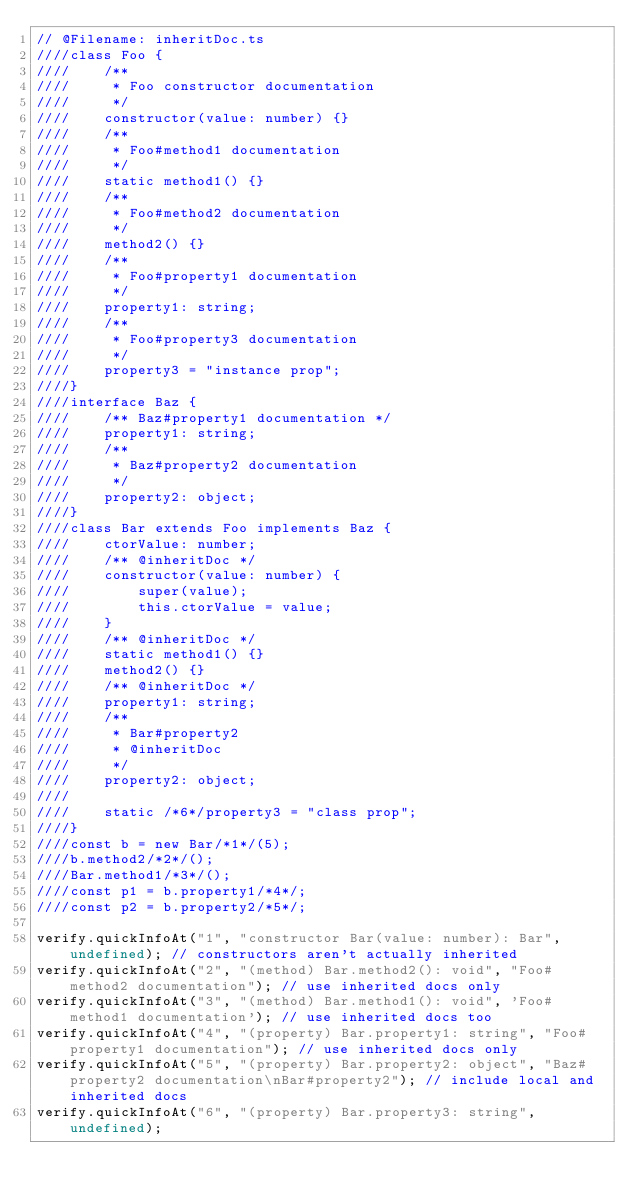Convert code to text. <code><loc_0><loc_0><loc_500><loc_500><_TypeScript_>// @Filename: inheritDoc.ts
////class Foo {
////    /**
////     * Foo constructor documentation
////     */
////    constructor(value: number) {}
////    /**
////     * Foo#method1 documentation
////     */
////    static method1() {}
////    /**
////     * Foo#method2 documentation
////     */
////    method2() {}
////    /**
////     * Foo#property1 documentation
////     */
////    property1: string;
////    /**
////     * Foo#property3 documentation
////     */
////    property3 = "instance prop";
////}
////interface Baz {
////    /** Baz#property1 documentation */
////    property1: string;
////    /**
////     * Baz#property2 documentation
////     */
////    property2: object;
////}
////class Bar extends Foo implements Baz {
////    ctorValue: number;
////    /** @inheritDoc */
////    constructor(value: number) {
////        super(value);
////        this.ctorValue = value;
////    }
////    /** @inheritDoc */
////    static method1() {}
////    method2() {}
////    /** @inheritDoc */
////    property1: string;
////    /**
////     * Bar#property2
////     * @inheritDoc
////     */
////    property2: object;
////
////    static /*6*/property3 = "class prop";
////}
////const b = new Bar/*1*/(5);
////b.method2/*2*/();
////Bar.method1/*3*/();
////const p1 = b.property1/*4*/;
////const p2 = b.property2/*5*/;

verify.quickInfoAt("1", "constructor Bar(value: number): Bar", undefined); // constructors aren't actually inherited
verify.quickInfoAt("2", "(method) Bar.method2(): void", "Foo#method2 documentation"); // use inherited docs only
verify.quickInfoAt("3", "(method) Bar.method1(): void", 'Foo#method1 documentation'); // use inherited docs too
verify.quickInfoAt("4", "(property) Bar.property1: string", "Foo#property1 documentation"); // use inherited docs only
verify.quickInfoAt("5", "(property) Bar.property2: object", "Baz#property2 documentation\nBar#property2"); // include local and inherited docs
verify.quickInfoAt("6", "(property) Bar.property3: string", undefined);
</code> 